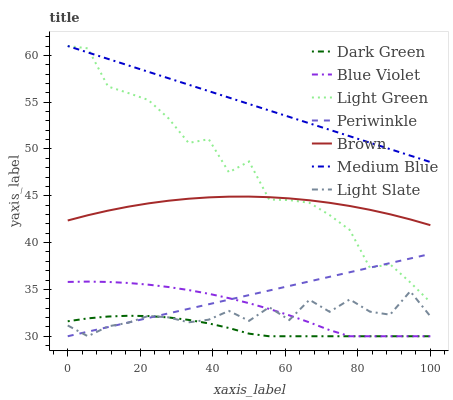Does Dark Green have the minimum area under the curve?
Answer yes or no. Yes. Does Medium Blue have the maximum area under the curve?
Answer yes or no. Yes. Does Light Slate have the minimum area under the curve?
Answer yes or no. No. Does Light Slate have the maximum area under the curve?
Answer yes or no. No. Is Medium Blue the smoothest?
Answer yes or no. Yes. Is Light Green the roughest?
Answer yes or no. Yes. Is Light Slate the smoothest?
Answer yes or no. No. Is Light Slate the roughest?
Answer yes or no. No. Does Light Slate have the lowest value?
Answer yes or no. Yes. Does Medium Blue have the lowest value?
Answer yes or no. No. Does Light Green have the highest value?
Answer yes or no. Yes. Does Light Slate have the highest value?
Answer yes or no. No. Is Periwinkle less than Brown?
Answer yes or no. Yes. Is Light Green greater than Light Slate?
Answer yes or no. Yes. Does Dark Green intersect Light Slate?
Answer yes or no. Yes. Is Dark Green less than Light Slate?
Answer yes or no. No. Is Dark Green greater than Light Slate?
Answer yes or no. No. Does Periwinkle intersect Brown?
Answer yes or no. No. 